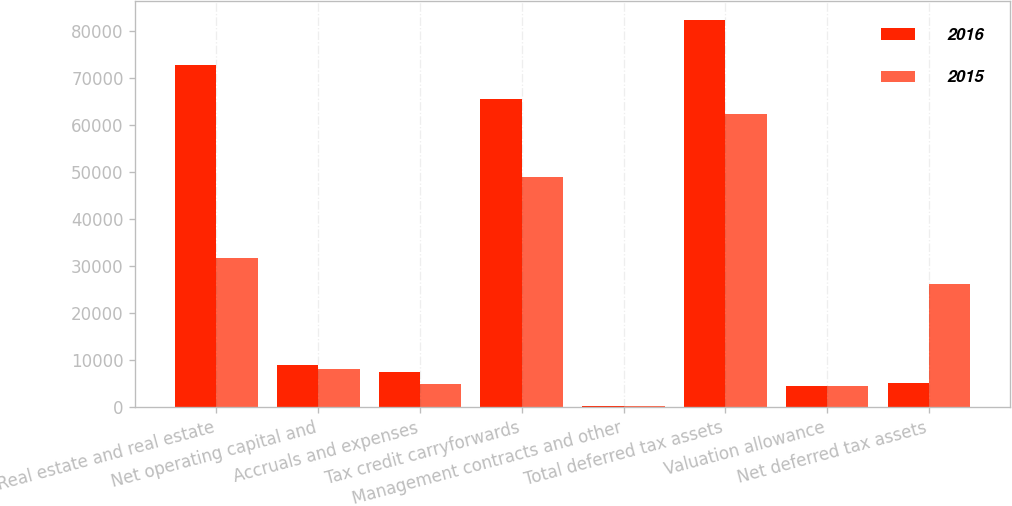Convert chart. <chart><loc_0><loc_0><loc_500><loc_500><stacked_bar_chart><ecel><fcel>Real estate and real estate<fcel>Net operating capital and<fcel>Accruals and expenses<fcel>Tax credit carryforwards<fcel>Management contracts and other<fcel>Total deferred tax assets<fcel>Valuation allowance<fcel>Net deferred tax assets<nl><fcel>2016<fcel>72726<fcel>8873<fcel>7537<fcel>65559<fcel>300<fcel>82269<fcel>4467<fcel>5076<nl><fcel>2015<fcel>31726<fcel>8024<fcel>4917<fcel>49036<fcel>333<fcel>62310<fcel>4467<fcel>26117<nl></chart> 